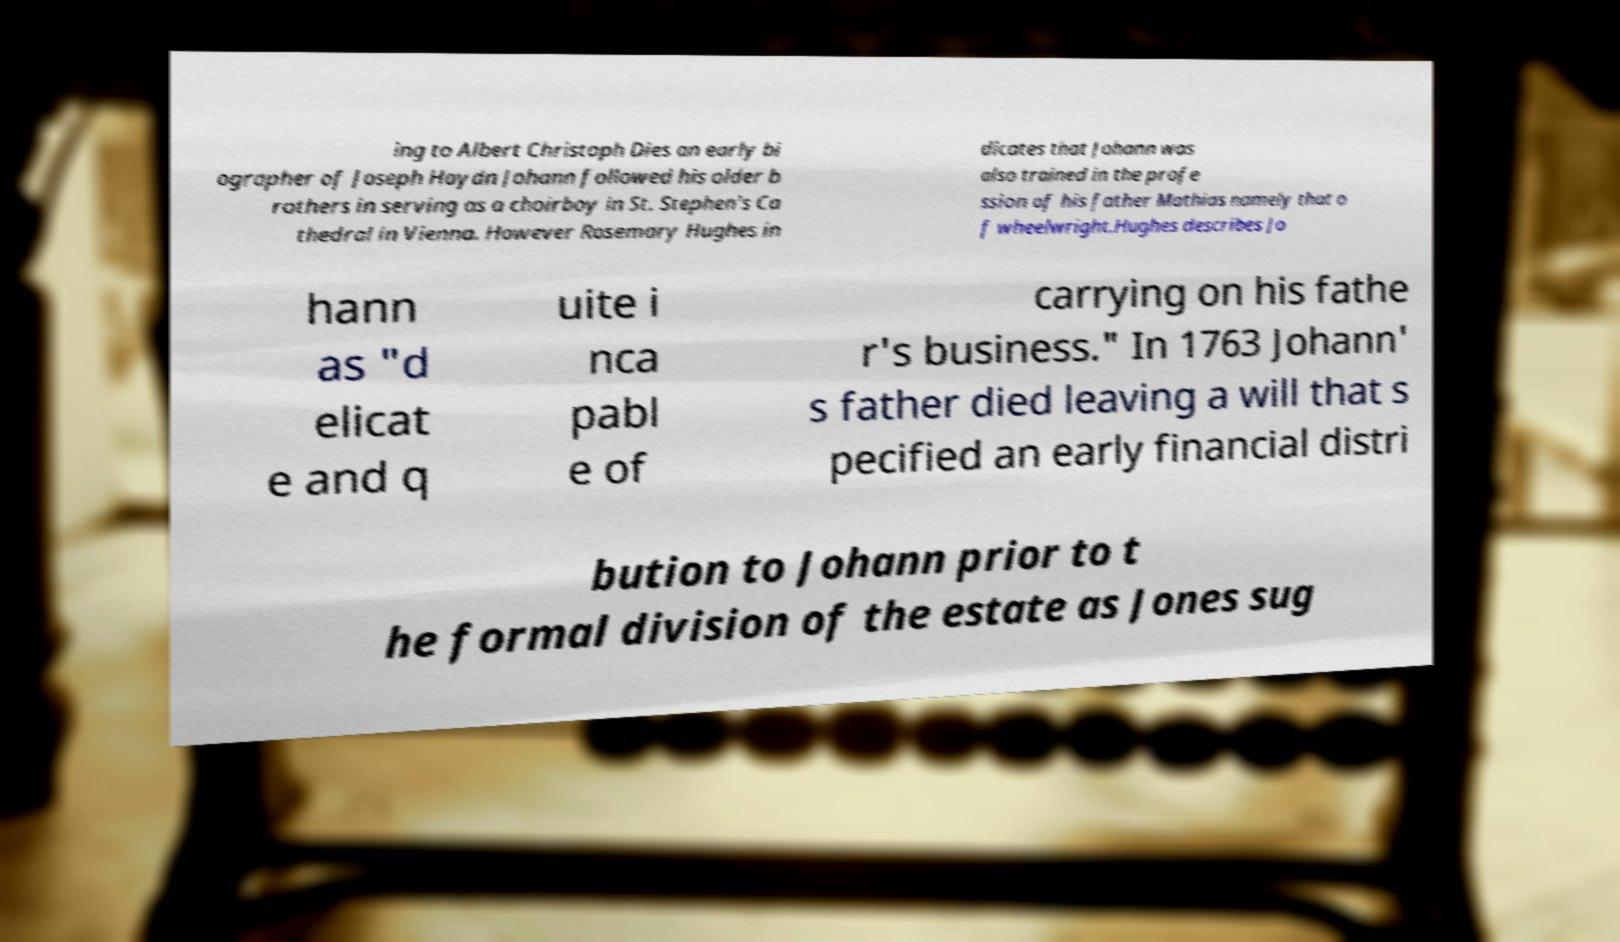Could you extract and type out the text from this image? ing to Albert Christoph Dies an early bi ographer of Joseph Haydn Johann followed his older b rothers in serving as a choirboy in St. Stephen's Ca thedral in Vienna. However Rosemary Hughes in dicates that Johann was also trained in the profe ssion of his father Mathias namely that o f wheelwright.Hughes describes Jo hann as "d elicat e and q uite i nca pabl e of carrying on his fathe r's business." In 1763 Johann' s father died leaving a will that s pecified an early financial distri bution to Johann prior to t he formal division of the estate as Jones sug 